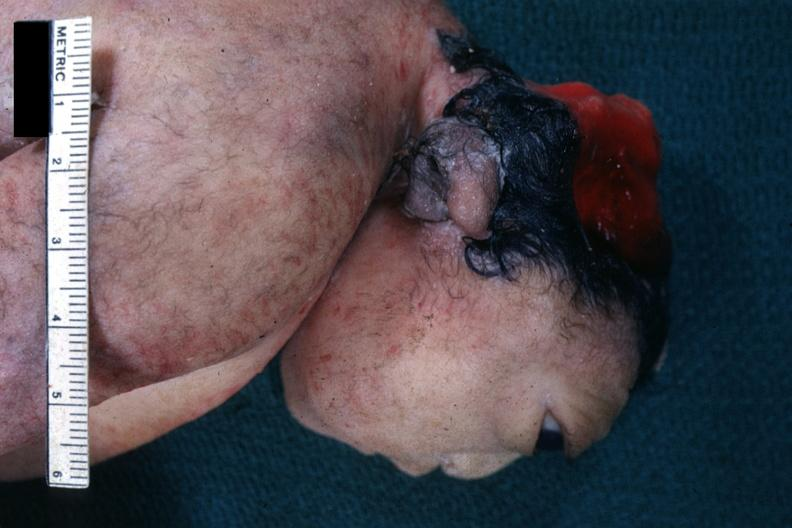s anencephaly present?
Answer the question using a single word or phrase. Yes 